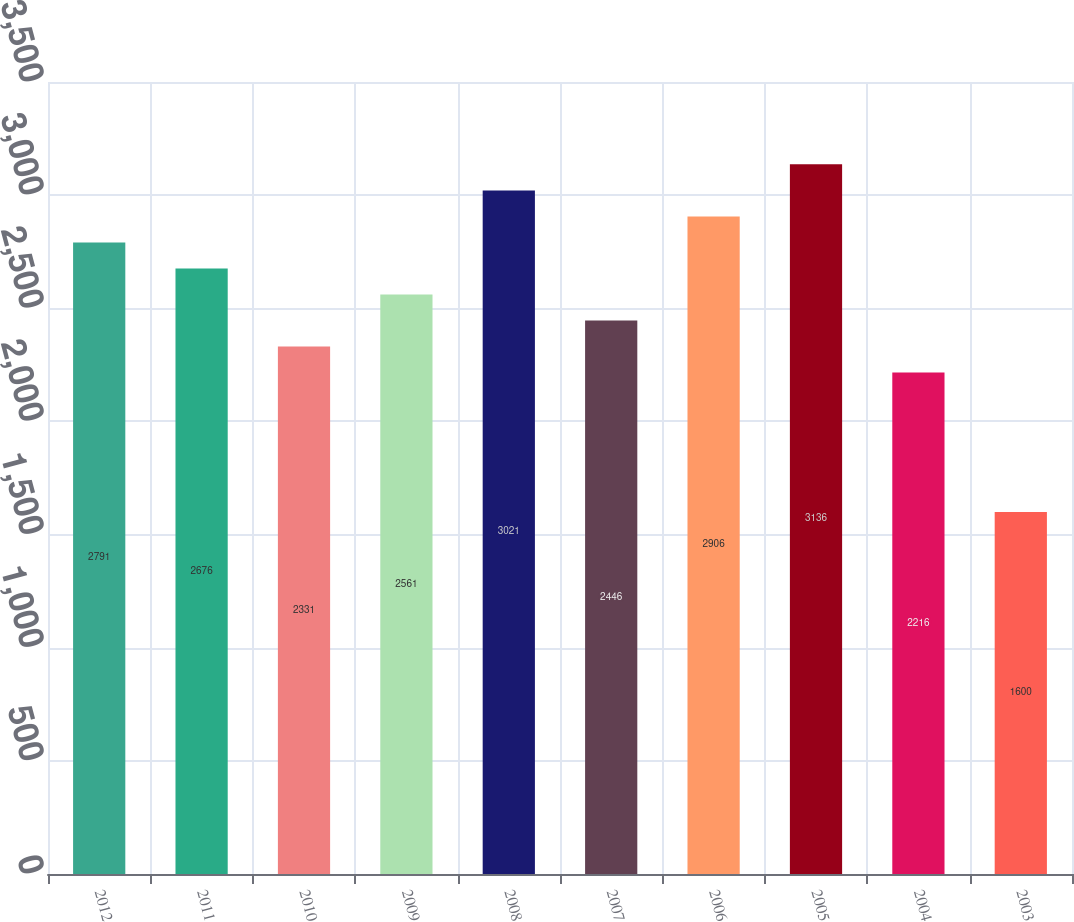Convert chart. <chart><loc_0><loc_0><loc_500><loc_500><bar_chart><fcel>2012<fcel>2011<fcel>2010<fcel>2009<fcel>2008<fcel>2007<fcel>2006<fcel>2005<fcel>2004<fcel>2003<nl><fcel>2791<fcel>2676<fcel>2331<fcel>2561<fcel>3021<fcel>2446<fcel>2906<fcel>3136<fcel>2216<fcel>1600<nl></chart> 